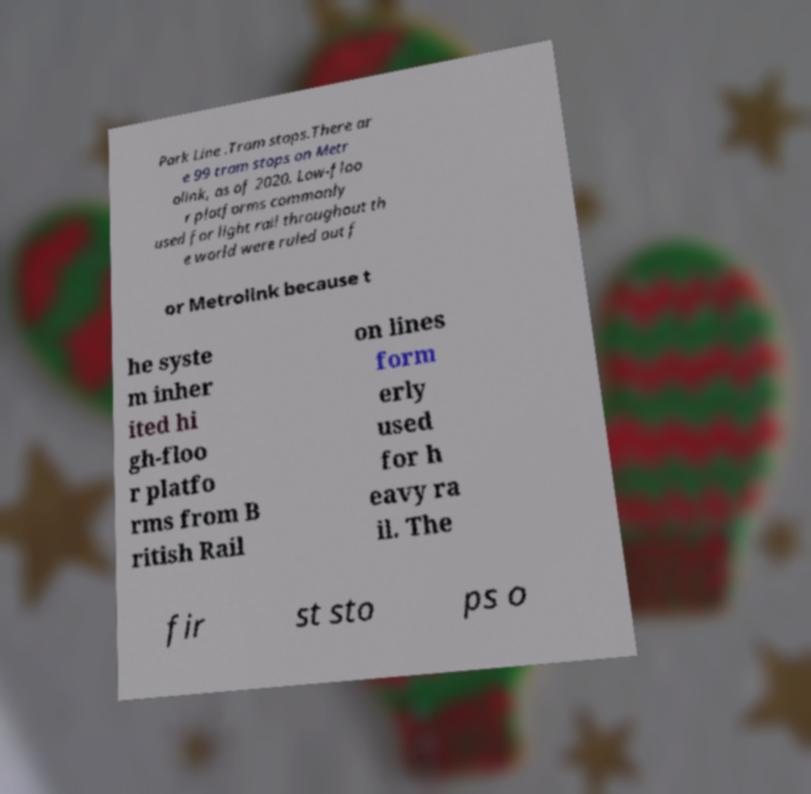Could you assist in decoding the text presented in this image and type it out clearly? Park Line .Tram stops.There ar e 99 tram stops on Metr olink, as of 2020. Low-floo r platforms commonly used for light rail throughout th e world were ruled out f or Metrolink because t he syste m inher ited hi gh-floo r platfo rms from B ritish Rail on lines form erly used for h eavy ra il. The fir st sto ps o 